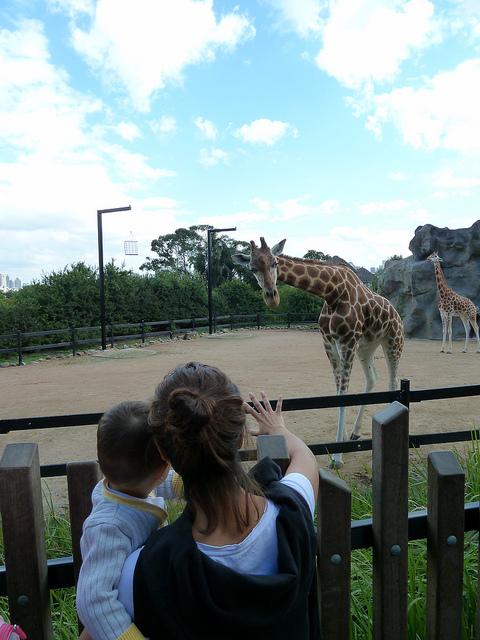Are they feeding the giraffe?
Quick response, please. No. What color is the woman's hair?
Write a very short answer. Brown. Where is the giraffe?
Quick response, please. In enclosure. Are those baby giraffes?
Quick response, please. No. They are waving at a giraffe?
Short answer required. Yes. What kind of animal are they waving at?
Concise answer only. Giraffe. 